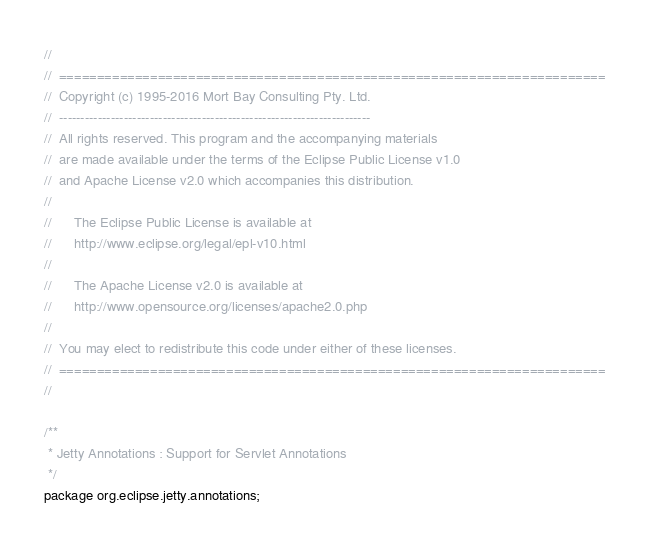Convert code to text. <code><loc_0><loc_0><loc_500><loc_500><_Java_>//
//  ========================================================================
//  Copyright (c) 1995-2016 Mort Bay Consulting Pty. Ltd.
//  ------------------------------------------------------------------------
//  All rights reserved. This program and the accompanying materials
//  are made available under the terms of the Eclipse Public License v1.0
//  and Apache License v2.0 which accompanies this distribution.
//
//      The Eclipse Public License is available at
//      http://www.eclipse.org/legal/epl-v10.html
//
//      The Apache License v2.0 is available at
//      http://www.opensource.org/licenses/apache2.0.php
//
//  You may elect to redistribute this code under either of these licenses.
//  ========================================================================
//

/**
 * Jetty Annotations : Support for Servlet Annotations
 */
package org.eclipse.jetty.annotations;

</code> 